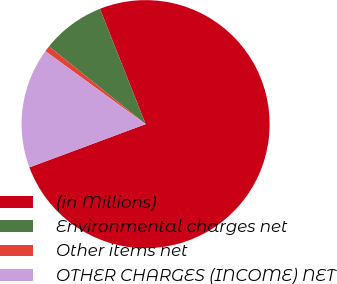<chart> <loc_0><loc_0><loc_500><loc_500><pie_chart><fcel>(in Millions)<fcel>Environmental charges net<fcel>Other items net<fcel>OTHER CHARGES (INCOME) NET<nl><fcel>75.33%<fcel>8.22%<fcel>0.77%<fcel>15.68%<nl></chart> 